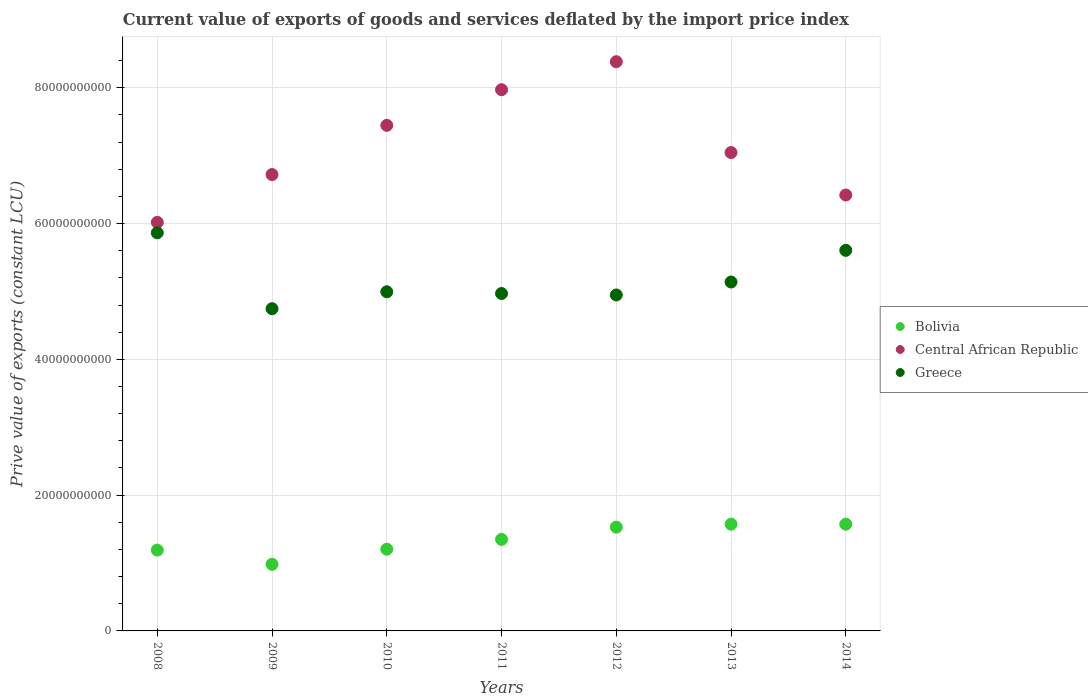How many different coloured dotlines are there?
Give a very brief answer. 3. What is the prive value of exports in Central African Republic in 2012?
Your answer should be very brief. 8.39e+1. Across all years, what is the maximum prive value of exports in Central African Republic?
Provide a short and direct response. 8.39e+1. Across all years, what is the minimum prive value of exports in Greece?
Keep it short and to the point. 4.75e+1. In which year was the prive value of exports in Bolivia maximum?
Provide a short and direct response. 2013. In which year was the prive value of exports in Central African Republic minimum?
Make the answer very short. 2008. What is the total prive value of exports in Greece in the graph?
Offer a terse response. 3.63e+11. What is the difference between the prive value of exports in Central African Republic in 2012 and that in 2013?
Offer a terse response. 1.34e+1. What is the difference between the prive value of exports in Bolivia in 2011 and the prive value of exports in Central African Republic in 2012?
Your answer should be very brief. -7.04e+1. What is the average prive value of exports in Central African Republic per year?
Give a very brief answer. 7.14e+1. In the year 2010, what is the difference between the prive value of exports in Greece and prive value of exports in Bolivia?
Offer a terse response. 3.79e+1. In how many years, is the prive value of exports in Central African Republic greater than 8000000000 LCU?
Provide a succinct answer. 7. What is the ratio of the prive value of exports in Greece in 2008 to that in 2011?
Provide a short and direct response. 1.18. Is the prive value of exports in Central African Republic in 2008 less than that in 2012?
Make the answer very short. Yes. Is the difference between the prive value of exports in Greece in 2008 and 2011 greater than the difference between the prive value of exports in Bolivia in 2008 and 2011?
Provide a short and direct response. Yes. What is the difference between the highest and the second highest prive value of exports in Greece?
Your answer should be very brief. 2.59e+09. What is the difference between the highest and the lowest prive value of exports in Greece?
Make the answer very short. 1.12e+1. In how many years, is the prive value of exports in Greece greater than the average prive value of exports in Greece taken over all years?
Your answer should be very brief. 2. Does the prive value of exports in Central African Republic monotonically increase over the years?
Your answer should be compact. No. What is the difference between two consecutive major ticks on the Y-axis?
Offer a very short reply. 2.00e+1. Are the values on the major ticks of Y-axis written in scientific E-notation?
Ensure brevity in your answer.  No. Does the graph contain any zero values?
Your answer should be very brief. No. Where does the legend appear in the graph?
Offer a terse response. Center right. How many legend labels are there?
Provide a succinct answer. 3. How are the legend labels stacked?
Offer a very short reply. Vertical. What is the title of the graph?
Give a very brief answer. Current value of exports of goods and services deflated by the import price index. Does "Malawi" appear as one of the legend labels in the graph?
Your answer should be very brief. No. What is the label or title of the Y-axis?
Keep it short and to the point. Prive value of exports (constant LCU). What is the Prive value of exports (constant LCU) of Bolivia in 2008?
Offer a terse response. 1.19e+1. What is the Prive value of exports (constant LCU) of Central African Republic in 2008?
Provide a short and direct response. 6.02e+1. What is the Prive value of exports (constant LCU) in Greece in 2008?
Provide a short and direct response. 5.86e+1. What is the Prive value of exports (constant LCU) in Bolivia in 2009?
Offer a terse response. 9.81e+09. What is the Prive value of exports (constant LCU) in Central African Republic in 2009?
Keep it short and to the point. 6.72e+1. What is the Prive value of exports (constant LCU) in Greece in 2009?
Your answer should be compact. 4.75e+1. What is the Prive value of exports (constant LCU) in Bolivia in 2010?
Provide a succinct answer. 1.20e+1. What is the Prive value of exports (constant LCU) in Central African Republic in 2010?
Make the answer very short. 7.45e+1. What is the Prive value of exports (constant LCU) in Greece in 2010?
Provide a short and direct response. 5.00e+1. What is the Prive value of exports (constant LCU) of Bolivia in 2011?
Ensure brevity in your answer.  1.35e+1. What is the Prive value of exports (constant LCU) of Central African Republic in 2011?
Ensure brevity in your answer.  7.97e+1. What is the Prive value of exports (constant LCU) in Greece in 2011?
Offer a very short reply. 4.97e+1. What is the Prive value of exports (constant LCU) of Bolivia in 2012?
Your response must be concise. 1.53e+1. What is the Prive value of exports (constant LCU) of Central African Republic in 2012?
Offer a terse response. 8.39e+1. What is the Prive value of exports (constant LCU) of Greece in 2012?
Keep it short and to the point. 4.95e+1. What is the Prive value of exports (constant LCU) of Bolivia in 2013?
Provide a succinct answer. 1.57e+1. What is the Prive value of exports (constant LCU) in Central African Republic in 2013?
Make the answer very short. 7.05e+1. What is the Prive value of exports (constant LCU) of Greece in 2013?
Offer a very short reply. 5.14e+1. What is the Prive value of exports (constant LCU) of Bolivia in 2014?
Your response must be concise. 1.57e+1. What is the Prive value of exports (constant LCU) in Central African Republic in 2014?
Provide a succinct answer. 6.42e+1. What is the Prive value of exports (constant LCU) of Greece in 2014?
Provide a succinct answer. 5.61e+1. Across all years, what is the maximum Prive value of exports (constant LCU) of Bolivia?
Keep it short and to the point. 1.57e+1. Across all years, what is the maximum Prive value of exports (constant LCU) of Central African Republic?
Your answer should be very brief. 8.39e+1. Across all years, what is the maximum Prive value of exports (constant LCU) of Greece?
Your response must be concise. 5.86e+1. Across all years, what is the minimum Prive value of exports (constant LCU) of Bolivia?
Your answer should be compact. 9.81e+09. Across all years, what is the minimum Prive value of exports (constant LCU) in Central African Republic?
Your response must be concise. 6.02e+1. Across all years, what is the minimum Prive value of exports (constant LCU) in Greece?
Give a very brief answer. 4.75e+1. What is the total Prive value of exports (constant LCU) in Bolivia in the graph?
Offer a terse response. 9.40e+1. What is the total Prive value of exports (constant LCU) in Central African Republic in the graph?
Offer a terse response. 5.00e+11. What is the total Prive value of exports (constant LCU) in Greece in the graph?
Your answer should be compact. 3.63e+11. What is the difference between the Prive value of exports (constant LCU) of Bolivia in 2008 and that in 2009?
Keep it short and to the point. 2.10e+09. What is the difference between the Prive value of exports (constant LCU) of Central African Republic in 2008 and that in 2009?
Your response must be concise. -7.05e+09. What is the difference between the Prive value of exports (constant LCU) in Greece in 2008 and that in 2009?
Provide a short and direct response. 1.12e+1. What is the difference between the Prive value of exports (constant LCU) in Bolivia in 2008 and that in 2010?
Provide a succinct answer. -1.35e+08. What is the difference between the Prive value of exports (constant LCU) in Central African Republic in 2008 and that in 2010?
Your answer should be compact. -1.43e+1. What is the difference between the Prive value of exports (constant LCU) of Greece in 2008 and that in 2010?
Give a very brief answer. 8.69e+09. What is the difference between the Prive value of exports (constant LCU) in Bolivia in 2008 and that in 2011?
Your response must be concise. -1.58e+09. What is the difference between the Prive value of exports (constant LCU) of Central African Republic in 2008 and that in 2011?
Offer a very short reply. -1.95e+1. What is the difference between the Prive value of exports (constant LCU) in Greece in 2008 and that in 2011?
Offer a very short reply. 8.95e+09. What is the difference between the Prive value of exports (constant LCU) in Bolivia in 2008 and that in 2012?
Make the answer very short. -3.38e+09. What is the difference between the Prive value of exports (constant LCU) of Central African Republic in 2008 and that in 2012?
Your answer should be very brief. -2.37e+1. What is the difference between the Prive value of exports (constant LCU) of Greece in 2008 and that in 2012?
Make the answer very short. 9.16e+09. What is the difference between the Prive value of exports (constant LCU) of Bolivia in 2008 and that in 2013?
Keep it short and to the point. -3.82e+09. What is the difference between the Prive value of exports (constant LCU) in Central African Republic in 2008 and that in 2013?
Ensure brevity in your answer.  -1.03e+1. What is the difference between the Prive value of exports (constant LCU) in Greece in 2008 and that in 2013?
Your response must be concise. 7.25e+09. What is the difference between the Prive value of exports (constant LCU) in Bolivia in 2008 and that in 2014?
Keep it short and to the point. -3.82e+09. What is the difference between the Prive value of exports (constant LCU) of Central African Republic in 2008 and that in 2014?
Your answer should be compact. -4.03e+09. What is the difference between the Prive value of exports (constant LCU) in Greece in 2008 and that in 2014?
Ensure brevity in your answer.  2.59e+09. What is the difference between the Prive value of exports (constant LCU) in Bolivia in 2009 and that in 2010?
Give a very brief answer. -2.23e+09. What is the difference between the Prive value of exports (constant LCU) in Central African Republic in 2009 and that in 2010?
Provide a short and direct response. -7.25e+09. What is the difference between the Prive value of exports (constant LCU) of Greece in 2009 and that in 2010?
Give a very brief answer. -2.49e+09. What is the difference between the Prive value of exports (constant LCU) of Bolivia in 2009 and that in 2011?
Offer a very short reply. -3.68e+09. What is the difference between the Prive value of exports (constant LCU) in Central African Republic in 2009 and that in 2011?
Provide a succinct answer. -1.25e+1. What is the difference between the Prive value of exports (constant LCU) in Greece in 2009 and that in 2011?
Your answer should be compact. -2.24e+09. What is the difference between the Prive value of exports (constant LCU) of Bolivia in 2009 and that in 2012?
Your response must be concise. -5.47e+09. What is the difference between the Prive value of exports (constant LCU) of Central African Republic in 2009 and that in 2012?
Provide a succinct answer. -1.66e+1. What is the difference between the Prive value of exports (constant LCU) of Greece in 2009 and that in 2012?
Offer a terse response. -2.02e+09. What is the difference between the Prive value of exports (constant LCU) of Bolivia in 2009 and that in 2013?
Your answer should be compact. -5.92e+09. What is the difference between the Prive value of exports (constant LCU) in Central African Republic in 2009 and that in 2013?
Keep it short and to the point. -3.24e+09. What is the difference between the Prive value of exports (constant LCU) in Greece in 2009 and that in 2013?
Your answer should be very brief. -3.93e+09. What is the difference between the Prive value of exports (constant LCU) in Bolivia in 2009 and that in 2014?
Provide a succinct answer. -5.91e+09. What is the difference between the Prive value of exports (constant LCU) of Central African Republic in 2009 and that in 2014?
Make the answer very short. 3.02e+09. What is the difference between the Prive value of exports (constant LCU) of Greece in 2009 and that in 2014?
Your answer should be compact. -8.60e+09. What is the difference between the Prive value of exports (constant LCU) in Bolivia in 2010 and that in 2011?
Your response must be concise. -1.44e+09. What is the difference between the Prive value of exports (constant LCU) of Central African Republic in 2010 and that in 2011?
Keep it short and to the point. -5.24e+09. What is the difference between the Prive value of exports (constant LCU) in Greece in 2010 and that in 2011?
Make the answer very short. 2.53e+08. What is the difference between the Prive value of exports (constant LCU) of Bolivia in 2010 and that in 2012?
Make the answer very short. -3.24e+09. What is the difference between the Prive value of exports (constant LCU) of Central African Republic in 2010 and that in 2012?
Ensure brevity in your answer.  -9.37e+09. What is the difference between the Prive value of exports (constant LCU) in Greece in 2010 and that in 2012?
Keep it short and to the point. 4.68e+08. What is the difference between the Prive value of exports (constant LCU) of Bolivia in 2010 and that in 2013?
Offer a very short reply. -3.69e+09. What is the difference between the Prive value of exports (constant LCU) of Central African Republic in 2010 and that in 2013?
Your answer should be very brief. 4.01e+09. What is the difference between the Prive value of exports (constant LCU) in Greece in 2010 and that in 2013?
Make the answer very short. -1.44e+09. What is the difference between the Prive value of exports (constant LCU) of Bolivia in 2010 and that in 2014?
Make the answer very short. -3.68e+09. What is the difference between the Prive value of exports (constant LCU) in Central African Republic in 2010 and that in 2014?
Provide a succinct answer. 1.03e+1. What is the difference between the Prive value of exports (constant LCU) of Greece in 2010 and that in 2014?
Provide a succinct answer. -6.11e+09. What is the difference between the Prive value of exports (constant LCU) of Bolivia in 2011 and that in 2012?
Ensure brevity in your answer.  -1.80e+09. What is the difference between the Prive value of exports (constant LCU) in Central African Republic in 2011 and that in 2012?
Offer a very short reply. -4.13e+09. What is the difference between the Prive value of exports (constant LCU) in Greece in 2011 and that in 2012?
Your answer should be very brief. 2.15e+08. What is the difference between the Prive value of exports (constant LCU) of Bolivia in 2011 and that in 2013?
Your answer should be very brief. -2.24e+09. What is the difference between the Prive value of exports (constant LCU) in Central African Republic in 2011 and that in 2013?
Ensure brevity in your answer.  9.25e+09. What is the difference between the Prive value of exports (constant LCU) in Greece in 2011 and that in 2013?
Give a very brief answer. -1.69e+09. What is the difference between the Prive value of exports (constant LCU) in Bolivia in 2011 and that in 2014?
Your response must be concise. -2.24e+09. What is the difference between the Prive value of exports (constant LCU) of Central African Republic in 2011 and that in 2014?
Your answer should be compact. 1.55e+1. What is the difference between the Prive value of exports (constant LCU) of Greece in 2011 and that in 2014?
Provide a short and direct response. -6.36e+09. What is the difference between the Prive value of exports (constant LCU) in Bolivia in 2012 and that in 2013?
Provide a succinct answer. -4.41e+08. What is the difference between the Prive value of exports (constant LCU) of Central African Republic in 2012 and that in 2013?
Keep it short and to the point. 1.34e+1. What is the difference between the Prive value of exports (constant LCU) in Greece in 2012 and that in 2013?
Provide a succinct answer. -1.91e+09. What is the difference between the Prive value of exports (constant LCU) in Bolivia in 2012 and that in 2014?
Ensure brevity in your answer.  -4.38e+08. What is the difference between the Prive value of exports (constant LCU) in Central African Republic in 2012 and that in 2014?
Provide a short and direct response. 1.96e+1. What is the difference between the Prive value of exports (constant LCU) of Greece in 2012 and that in 2014?
Keep it short and to the point. -6.57e+09. What is the difference between the Prive value of exports (constant LCU) of Bolivia in 2013 and that in 2014?
Ensure brevity in your answer.  2.36e+06. What is the difference between the Prive value of exports (constant LCU) in Central African Republic in 2013 and that in 2014?
Ensure brevity in your answer.  6.26e+09. What is the difference between the Prive value of exports (constant LCU) of Greece in 2013 and that in 2014?
Give a very brief answer. -4.67e+09. What is the difference between the Prive value of exports (constant LCU) in Bolivia in 2008 and the Prive value of exports (constant LCU) in Central African Republic in 2009?
Provide a succinct answer. -5.53e+1. What is the difference between the Prive value of exports (constant LCU) of Bolivia in 2008 and the Prive value of exports (constant LCU) of Greece in 2009?
Give a very brief answer. -3.56e+1. What is the difference between the Prive value of exports (constant LCU) of Central African Republic in 2008 and the Prive value of exports (constant LCU) of Greece in 2009?
Provide a short and direct response. 1.27e+1. What is the difference between the Prive value of exports (constant LCU) of Bolivia in 2008 and the Prive value of exports (constant LCU) of Central African Republic in 2010?
Provide a short and direct response. -6.26e+1. What is the difference between the Prive value of exports (constant LCU) in Bolivia in 2008 and the Prive value of exports (constant LCU) in Greece in 2010?
Provide a short and direct response. -3.81e+1. What is the difference between the Prive value of exports (constant LCU) in Central African Republic in 2008 and the Prive value of exports (constant LCU) in Greece in 2010?
Your response must be concise. 1.02e+1. What is the difference between the Prive value of exports (constant LCU) of Bolivia in 2008 and the Prive value of exports (constant LCU) of Central African Republic in 2011?
Provide a short and direct response. -6.78e+1. What is the difference between the Prive value of exports (constant LCU) in Bolivia in 2008 and the Prive value of exports (constant LCU) in Greece in 2011?
Your response must be concise. -3.78e+1. What is the difference between the Prive value of exports (constant LCU) of Central African Republic in 2008 and the Prive value of exports (constant LCU) of Greece in 2011?
Your answer should be very brief. 1.05e+1. What is the difference between the Prive value of exports (constant LCU) in Bolivia in 2008 and the Prive value of exports (constant LCU) in Central African Republic in 2012?
Your answer should be very brief. -7.19e+1. What is the difference between the Prive value of exports (constant LCU) of Bolivia in 2008 and the Prive value of exports (constant LCU) of Greece in 2012?
Ensure brevity in your answer.  -3.76e+1. What is the difference between the Prive value of exports (constant LCU) in Central African Republic in 2008 and the Prive value of exports (constant LCU) in Greece in 2012?
Ensure brevity in your answer.  1.07e+1. What is the difference between the Prive value of exports (constant LCU) of Bolivia in 2008 and the Prive value of exports (constant LCU) of Central African Republic in 2013?
Your response must be concise. -5.86e+1. What is the difference between the Prive value of exports (constant LCU) of Bolivia in 2008 and the Prive value of exports (constant LCU) of Greece in 2013?
Ensure brevity in your answer.  -3.95e+1. What is the difference between the Prive value of exports (constant LCU) in Central African Republic in 2008 and the Prive value of exports (constant LCU) in Greece in 2013?
Your answer should be very brief. 8.78e+09. What is the difference between the Prive value of exports (constant LCU) of Bolivia in 2008 and the Prive value of exports (constant LCU) of Central African Republic in 2014?
Offer a terse response. -5.23e+1. What is the difference between the Prive value of exports (constant LCU) of Bolivia in 2008 and the Prive value of exports (constant LCU) of Greece in 2014?
Your answer should be compact. -4.42e+1. What is the difference between the Prive value of exports (constant LCU) in Central African Republic in 2008 and the Prive value of exports (constant LCU) in Greece in 2014?
Make the answer very short. 4.12e+09. What is the difference between the Prive value of exports (constant LCU) in Bolivia in 2009 and the Prive value of exports (constant LCU) in Central African Republic in 2010?
Give a very brief answer. -6.47e+1. What is the difference between the Prive value of exports (constant LCU) in Bolivia in 2009 and the Prive value of exports (constant LCU) in Greece in 2010?
Offer a very short reply. -4.01e+1. What is the difference between the Prive value of exports (constant LCU) of Central African Republic in 2009 and the Prive value of exports (constant LCU) of Greece in 2010?
Give a very brief answer. 1.73e+1. What is the difference between the Prive value of exports (constant LCU) in Bolivia in 2009 and the Prive value of exports (constant LCU) in Central African Republic in 2011?
Your response must be concise. -6.99e+1. What is the difference between the Prive value of exports (constant LCU) in Bolivia in 2009 and the Prive value of exports (constant LCU) in Greece in 2011?
Your answer should be compact. -3.99e+1. What is the difference between the Prive value of exports (constant LCU) of Central African Republic in 2009 and the Prive value of exports (constant LCU) of Greece in 2011?
Your answer should be very brief. 1.75e+1. What is the difference between the Prive value of exports (constant LCU) in Bolivia in 2009 and the Prive value of exports (constant LCU) in Central African Republic in 2012?
Make the answer very short. -7.40e+1. What is the difference between the Prive value of exports (constant LCU) of Bolivia in 2009 and the Prive value of exports (constant LCU) of Greece in 2012?
Your answer should be compact. -3.97e+1. What is the difference between the Prive value of exports (constant LCU) in Central African Republic in 2009 and the Prive value of exports (constant LCU) in Greece in 2012?
Ensure brevity in your answer.  1.77e+1. What is the difference between the Prive value of exports (constant LCU) in Bolivia in 2009 and the Prive value of exports (constant LCU) in Central African Republic in 2013?
Your answer should be compact. -6.07e+1. What is the difference between the Prive value of exports (constant LCU) in Bolivia in 2009 and the Prive value of exports (constant LCU) in Greece in 2013?
Offer a terse response. -4.16e+1. What is the difference between the Prive value of exports (constant LCU) in Central African Republic in 2009 and the Prive value of exports (constant LCU) in Greece in 2013?
Offer a terse response. 1.58e+1. What is the difference between the Prive value of exports (constant LCU) in Bolivia in 2009 and the Prive value of exports (constant LCU) in Central African Republic in 2014?
Keep it short and to the point. -5.44e+1. What is the difference between the Prive value of exports (constant LCU) in Bolivia in 2009 and the Prive value of exports (constant LCU) in Greece in 2014?
Give a very brief answer. -4.63e+1. What is the difference between the Prive value of exports (constant LCU) in Central African Republic in 2009 and the Prive value of exports (constant LCU) in Greece in 2014?
Your answer should be compact. 1.12e+1. What is the difference between the Prive value of exports (constant LCU) of Bolivia in 2010 and the Prive value of exports (constant LCU) of Central African Republic in 2011?
Offer a terse response. -6.77e+1. What is the difference between the Prive value of exports (constant LCU) in Bolivia in 2010 and the Prive value of exports (constant LCU) in Greece in 2011?
Your answer should be very brief. -3.77e+1. What is the difference between the Prive value of exports (constant LCU) of Central African Republic in 2010 and the Prive value of exports (constant LCU) of Greece in 2011?
Provide a succinct answer. 2.48e+1. What is the difference between the Prive value of exports (constant LCU) in Bolivia in 2010 and the Prive value of exports (constant LCU) in Central African Republic in 2012?
Keep it short and to the point. -7.18e+1. What is the difference between the Prive value of exports (constant LCU) of Bolivia in 2010 and the Prive value of exports (constant LCU) of Greece in 2012?
Give a very brief answer. -3.74e+1. What is the difference between the Prive value of exports (constant LCU) in Central African Republic in 2010 and the Prive value of exports (constant LCU) in Greece in 2012?
Keep it short and to the point. 2.50e+1. What is the difference between the Prive value of exports (constant LCU) of Bolivia in 2010 and the Prive value of exports (constant LCU) of Central African Republic in 2013?
Your answer should be compact. -5.84e+1. What is the difference between the Prive value of exports (constant LCU) of Bolivia in 2010 and the Prive value of exports (constant LCU) of Greece in 2013?
Offer a very short reply. -3.94e+1. What is the difference between the Prive value of exports (constant LCU) of Central African Republic in 2010 and the Prive value of exports (constant LCU) of Greece in 2013?
Ensure brevity in your answer.  2.31e+1. What is the difference between the Prive value of exports (constant LCU) of Bolivia in 2010 and the Prive value of exports (constant LCU) of Central African Republic in 2014?
Your answer should be compact. -5.22e+1. What is the difference between the Prive value of exports (constant LCU) of Bolivia in 2010 and the Prive value of exports (constant LCU) of Greece in 2014?
Your answer should be very brief. -4.40e+1. What is the difference between the Prive value of exports (constant LCU) of Central African Republic in 2010 and the Prive value of exports (constant LCU) of Greece in 2014?
Keep it short and to the point. 1.84e+1. What is the difference between the Prive value of exports (constant LCU) of Bolivia in 2011 and the Prive value of exports (constant LCU) of Central African Republic in 2012?
Offer a very short reply. -7.04e+1. What is the difference between the Prive value of exports (constant LCU) in Bolivia in 2011 and the Prive value of exports (constant LCU) in Greece in 2012?
Your response must be concise. -3.60e+1. What is the difference between the Prive value of exports (constant LCU) of Central African Republic in 2011 and the Prive value of exports (constant LCU) of Greece in 2012?
Offer a very short reply. 3.02e+1. What is the difference between the Prive value of exports (constant LCU) in Bolivia in 2011 and the Prive value of exports (constant LCU) in Central African Republic in 2013?
Your answer should be very brief. -5.70e+1. What is the difference between the Prive value of exports (constant LCU) in Bolivia in 2011 and the Prive value of exports (constant LCU) in Greece in 2013?
Provide a succinct answer. -3.79e+1. What is the difference between the Prive value of exports (constant LCU) of Central African Republic in 2011 and the Prive value of exports (constant LCU) of Greece in 2013?
Your answer should be very brief. 2.83e+1. What is the difference between the Prive value of exports (constant LCU) in Bolivia in 2011 and the Prive value of exports (constant LCU) in Central African Republic in 2014?
Provide a short and direct response. -5.07e+1. What is the difference between the Prive value of exports (constant LCU) in Bolivia in 2011 and the Prive value of exports (constant LCU) in Greece in 2014?
Your answer should be compact. -4.26e+1. What is the difference between the Prive value of exports (constant LCU) in Central African Republic in 2011 and the Prive value of exports (constant LCU) in Greece in 2014?
Provide a short and direct response. 2.37e+1. What is the difference between the Prive value of exports (constant LCU) of Bolivia in 2012 and the Prive value of exports (constant LCU) of Central African Republic in 2013?
Give a very brief answer. -5.52e+1. What is the difference between the Prive value of exports (constant LCU) of Bolivia in 2012 and the Prive value of exports (constant LCU) of Greece in 2013?
Offer a very short reply. -3.61e+1. What is the difference between the Prive value of exports (constant LCU) in Central African Republic in 2012 and the Prive value of exports (constant LCU) in Greece in 2013?
Your answer should be very brief. 3.25e+1. What is the difference between the Prive value of exports (constant LCU) in Bolivia in 2012 and the Prive value of exports (constant LCU) in Central African Republic in 2014?
Your response must be concise. -4.89e+1. What is the difference between the Prive value of exports (constant LCU) in Bolivia in 2012 and the Prive value of exports (constant LCU) in Greece in 2014?
Your response must be concise. -4.08e+1. What is the difference between the Prive value of exports (constant LCU) in Central African Republic in 2012 and the Prive value of exports (constant LCU) in Greece in 2014?
Provide a succinct answer. 2.78e+1. What is the difference between the Prive value of exports (constant LCU) in Bolivia in 2013 and the Prive value of exports (constant LCU) in Central African Republic in 2014?
Your answer should be compact. -4.85e+1. What is the difference between the Prive value of exports (constant LCU) of Bolivia in 2013 and the Prive value of exports (constant LCU) of Greece in 2014?
Provide a succinct answer. -4.03e+1. What is the difference between the Prive value of exports (constant LCU) in Central African Republic in 2013 and the Prive value of exports (constant LCU) in Greece in 2014?
Your response must be concise. 1.44e+1. What is the average Prive value of exports (constant LCU) of Bolivia per year?
Ensure brevity in your answer.  1.34e+1. What is the average Prive value of exports (constant LCU) of Central African Republic per year?
Provide a short and direct response. 7.14e+1. What is the average Prive value of exports (constant LCU) in Greece per year?
Provide a short and direct response. 5.18e+1. In the year 2008, what is the difference between the Prive value of exports (constant LCU) of Bolivia and Prive value of exports (constant LCU) of Central African Republic?
Ensure brevity in your answer.  -4.83e+1. In the year 2008, what is the difference between the Prive value of exports (constant LCU) in Bolivia and Prive value of exports (constant LCU) in Greece?
Make the answer very short. -4.67e+1. In the year 2008, what is the difference between the Prive value of exports (constant LCU) in Central African Republic and Prive value of exports (constant LCU) in Greece?
Ensure brevity in your answer.  1.53e+09. In the year 2009, what is the difference between the Prive value of exports (constant LCU) of Bolivia and Prive value of exports (constant LCU) of Central African Republic?
Give a very brief answer. -5.74e+1. In the year 2009, what is the difference between the Prive value of exports (constant LCU) in Bolivia and Prive value of exports (constant LCU) in Greece?
Offer a very short reply. -3.77e+1. In the year 2009, what is the difference between the Prive value of exports (constant LCU) of Central African Republic and Prive value of exports (constant LCU) of Greece?
Offer a terse response. 1.98e+1. In the year 2010, what is the difference between the Prive value of exports (constant LCU) in Bolivia and Prive value of exports (constant LCU) in Central African Republic?
Make the answer very short. -6.24e+1. In the year 2010, what is the difference between the Prive value of exports (constant LCU) of Bolivia and Prive value of exports (constant LCU) of Greece?
Keep it short and to the point. -3.79e+1. In the year 2010, what is the difference between the Prive value of exports (constant LCU) in Central African Republic and Prive value of exports (constant LCU) in Greece?
Give a very brief answer. 2.45e+1. In the year 2011, what is the difference between the Prive value of exports (constant LCU) in Bolivia and Prive value of exports (constant LCU) in Central African Republic?
Offer a terse response. -6.62e+1. In the year 2011, what is the difference between the Prive value of exports (constant LCU) in Bolivia and Prive value of exports (constant LCU) in Greece?
Provide a succinct answer. -3.62e+1. In the year 2011, what is the difference between the Prive value of exports (constant LCU) of Central African Republic and Prive value of exports (constant LCU) of Greece?
Keep it short and to the point. 3.00e+1. In the year 2012, what is the difference between the Prive value of exports (constant LCU) of Bolivia and Prive value of exports (constant LCU) of Central African Republic?
Offer a terse response. -6.86e+1. In the year 2012, what is the difference between the Prive value of exports (constant LCU) in Bolivia and Prive value of exports (constant LCU) in Greece?
Ensure brevity in your answer.  -3.42e+1. In the year 2012, what is the difference between the Prive value of exports (constant LCU) in Central African Republic and Prive value of exports (constant LCU) in Greece?
Your response must be concise. 3.44e+1. In the year 2013, what is the difference between the Prive value of exports (constant LCU) of Bolivia and Prive value of exports (constant LCU) of Central African Republic?
Provide a short and direct response. -5.47e+1. In the year 2013, what is the difference between the Prive value of exports (constant LCU) in Bolivia and Prive value of exports (constant LCU) in Greece?
Offer a terse response. -3.57e+1. In the year 2013, what is the difference between the Prive value of exports (constant LCU) of Central African Republic and Prive value of exports (constant LCU) of Greece?
Offer a very short reply. 1.91e+1. In the year 2014, what is the difference between the Prive value of exports (constant LCU) in Bolivia and Prive value of exports (constant LCU) in Central African Republic?
Provide a succinct answer. -4.85e+1. In the year 2014, what is the difference between the Prive value of exports (constant LCU) in Bolivia and Prive value of exports (constant LCU) in Greece?
Your answer should be very brief. -4.03e+1. In the year 2014, what is the difference between the Prive value of exports (constant LCU) of Central African Republic and Prive value of exports (constant LCU) of Greece?
Your answer should be very brief. 8.15e+09. What is the ratio of the Prive value of exports (constant LCU) of Bolivia in 2008 to that in 2009?
Offer a very short reply. 1.21. What is the ratio of the Prive value of exports (constant LCU) of Central African Republic in 2008 to that in 2009?
Keep it short and to the point. 0.9. What is the ratio of the Prive value of exports (constant LCU) of Greece in 2008 to that in 2009?
Give a very brief answer. 1.24. What is the ratio of the Prive value of exports (constant LCU) in Central African Republic in 2008 to that in 2010?
Give a very brief answer. 0.81. What is the ratio of the Prive value of exports (constant LCU) of Greece in 2008 to that in 2010?
Provide a succinct answer. 1.17. What is the ratio of the Prive value of exports (constant LCU) of Bolivia in 2008 to that in 2011?
Make the answer very short. 0.88. What is the ratio of the Prive value of exports (constant LCU) of Central African Republic in 2008 to that in 2011?
Your response must be concise. 0.75. What is the ratio of the Prive value of exports (constant LCU) in Greece in 2008 to that in 2011?
Your answer should be compact. 1.18. What is the ratio of the Prive value of exports (constant LCU) of Bolivia in 2008 to that in 2012?
Your response must be concise. 0.78. What is the ratio of the Prive value of exports (constant LCU) of Central African Republic in 2008 to that in 2012?
Ensure brevity in your answer.  0.72. What is the ratio of the Prive value of exports (constant LCU) of Greece in 2008 to that in 2012?
Ensure brevity in your answer.  1.19. What is the ratio of the Prive value of exports (constant LCU) of Bolivia in 2008 to that in 2013?
Provide a short and direct response. 0.76. What is the ratio of the Prive value of exports (constant LCU) of Central African Republic in 2008 to that in 2013?
Offer a very short reply. 0.85. What is the ratio of the Prive value of exports (constant LCU) of Greece in 2008 to that in 2013?
Keep it short and to the point. 1.14. What is the ratio of the Prive value of exports (constant LCU) in Bolivia in 2008 to that in 2014?
Ensure brevity in your answer.  0.76. What is the ratio of the Prive value of exports (constant LCU) in Central African Republic in 2008 to that in 2014?
Keep it short and to the point. 0.94. What is the ratio of the Prive value of exports (constant LCU) of Greece in 2008 to that in 2014?
Ensure brevity in your answer.  1.05. What is the ratio of the Prive value of exports (constant LCU) of Bolivia in 2009 to that in 2010?
Your answer should be very brief. 0.81. What is the ratio of the Prive value of exports (constant LCU) of Central African Republic in 2009 to that in 2010?
Offer a very short reply. 0.9. What is the ratio of the Prive value of exports (constant LCU) in Greece in 2009 to that in 2010?
Provide a short and direct response. 0.95. What is the ratio of the Prive value of exports (constant LCU) in Bolivia in 2009 to that in 2011?
Offer a very short reply. 0.73. What is the ratio of the Prive value of exports (constant LCU) of Central African Republic in 2009 to that in 2011?
Your answer should be compact. 0.84. What is the ratio of the Prive value of exports (constant LCU) of Greece in 2009 to that in 2011?
Ensure brevity in your answer.  0.95. What is the ratio of the Prive value of exports (constant LCU) in Bolivia in 2009 to that in 2012?
Ensure brevity in your answer.  0.64. What is the ratio of the Prive value of exports (constant LCU) of Central African Republic in 2009 to that in 2012?
Ensure brevity in your answer.  0.8. What is the ratio of the Prive value of exports (constant LCU) in Greece in 2009 to that in 2012?
Ensure brevity in your answer.  0.96. What is the ratio of the Prive value of exports (constant LCU) of Bolivia in 2009 to that in 2013?
Your answer should be compact. 0.62. What is the ratio of the Prive value of exports (constant LCU) of Central African Republic in 2009 to that in 2013?
Give a very brief answer. 0.95. What is the ratio of the Prive value of exports (constant LCU) in Greece in 2009 to that in 2013?
Your answer should be very brief. 0.92. What is the ratio of the Prive value of exports (constant LCU) in Bolivia in 2009 to that in 2014?
Your response must be concise. 0.62. What is the ratio of the Prive value of exports (constant LCU) of Central African Republic in 2009 to that in 2014?
Your response must be concise. 1.05. What is the ratio of the Prive value of exports (constant LCU) of Greece in 2009 to that in 2014?
Ensure brevity in your answer.  0.85. What is the ratio of the Prive value of exports (constant LCU) of Bolivia in 2010 to that in 2011?
Your answer should be very brief. 0.89. What is the ratio of the Prive value of exports (constant LCU) in Central African Republic in 2010 to that in 2011?
Provide a short and direct response. 0.93. What is the ratio of the Prive value of exports (constant LCU) in Greece in 2010 to that in 2011?
Offer a very short reply. 1.01. What is the ratio of the Prive value of exports (constant LCU) in Bolivia in 2010 to that in 2012?
Your response must be concise. 0.79. What is the ratio of the Prive value of exports (constant LCU) of Central African Republic in 2010 to that in 2012?
Your answer should be very brief. 0.89. What is the ratio of the Prive value of exports (constant LCU) in Greece in 2010 to that in 2012?
Offer a very short reply. 1.01. What is the ratio of the Prive value of exports (constant LCU) of Bolivia in 2010 to that in 2013?
Your answer should be compact. 0.77. What is the ratio of the Prive value of exports (constant LCU) of Central African Republic in 2010 to that in 2013?
Provide a succinct answer. 1.06. What is the ratio of the Prive value of exports (constant LCU) of Greece in 2010 to that in 2013?
Your answer should be compact. 0.97. What is the ratio of the Prive value of exports (constant LCU) of Bolivia in 2010 to that in 2014?
Provide a short and direct response. 0.77. What is the ratio of the Prive value of exports (constant LCU) in Central African Republic in 2010 to that in 2014?
Offer a terse response. 1.16. What is the ratio of the Prive value of exports (constant LCU) in Greece in 2010 to that in 2014?
Provide a succinct answer. 0.89. What is the ratio of the Prive value of exports (constant LCU) of Bolivia in 2011 to that in 2012?
Your answer should be compact. 0.88. What is the ratio of the Prive value of exports (constant LCU) in Central African Republic in 2011 to that in 2012?
Provide a short and direct response. 0.95. What is the ratio of the Prive value of exports (constant LCU) of Greece in 2011 to that in 2012?
Offer a terse response. 1. What is the ratio of the Prive value of exports (constant LCU) in Bolivia in 2011 to that in 2013?
Ensure brevity in your answer.  0.86. What is the ratio of the Prive value of exports (constant LCU) of Central African Republic in 2011 to that in 2013?
Your response must be concise. 1.13. What is the ratio of the Prive value of exports (constant LCU) in Bolivia in 2011 to that in 2014?
Your answer should be very brief. 0.86. What is the ratio of the Prive value of exports (constant LCU) of Central African Republic in 2011 to that in 2014?
Provide a succinct answer. 1.24. What is the ratio of the Prive value of exports (constant LCU) in Greece in 2011 to that in 2014?
Give a very brief answer. 0.89. What is the ratio of the Prive value of exports (constant LCU) of Bolivia in 2012 to that in 2013?
Make the answer very short. 0.97. What is the ratio of the Prive value of exports (constant LCU) of Central African Republic in 2012 to that in 2013?
Provide a succinct answer. 1.19. What is the ratio of the Prive value of exports (constant LCU) of Greece in 2012 to that in 2013?
Provide a succinct answer. 0.96. What is the ratio of the Prive value of exports (constant LCU) in Bolivia in 2012 to that in 2014?
Give a very brief answer. 0.97. What is the ratio of the Prive value of exports (constant LCU) of Central African Republic in 2012 to that in 2014?
Your answer should be compact. 1.31. What is the ratio of the Prive value of exports (constant LCU) of Greece in 2012 to that in 2014?
Your answer should be compact. 0.88. What is the ratio of the Prive value of exports (constant LCU) of Bolivia in 2013 to that in 2014?
Make the answer very short. 1. What is the ratio of the Prive value of exports (constant LCU) in Central African Republic in 2013 to that in 2014?
Offer a very short reply. 1.1. What is the ratio of the Prive value of exports (constant LCU) of Greece in 2013 to that in 2014?
Give a very brief answer. 0.92. What is the difference between the highest and the second highest Prive value of exports (constant LCU) in Bolivia?
Offer a terse response. 2.36e+06. What is the difference between the highest and the second highest Prive value of exports (constant LCU) in Central African Republic?
Offer a very short reply. 4.13e+09. What is the difference between the highest and the second highest Prive value of exports (constant LCU) of Greece?
Ensure brevity in your answer.  2.59e+09. What is the difference between the highest and the lowest Prive value of exports (constant LCU) of Bolivia?
Keep it short and to the point. 5.92e+09. What is the difference between the highest and the lowest Prive value of exports (constant LCU) in Central African Republic?
Provide a succinct answer. 2.37e+1. What is the difference between the highest and the lowest Prive value of exports (constant LCU) of Greece?
Offer a very short reply. 1.12e+1. 